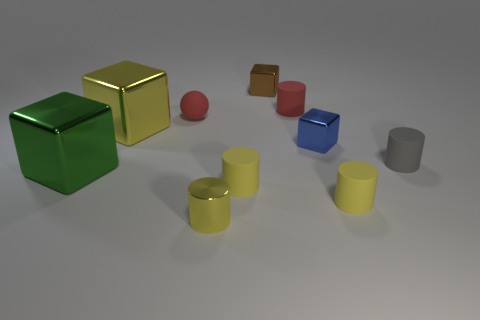Subtract all yellow cylinders. How many were subtracted if there are1yellow cylinders left? 2 Subtract all red blocks. How many yellow cylinders are left? 3 Subtract 3 cylinders. How many cylinders are left? 2 Subtract all gray cylinders. How many cylinders are left? 4 Subtract all small metallic cylinders. How many cylinders are left? 4 Subtract all red cubes. Subtract all yellow balls. How many cubes are left? 4 Subtract all spheres. How many objects are left? 9 Add 5 big blocks. How many big blocks exist? 7 Subtract 1 gray cylinders. How many objects are left? 9 Subtract all yellow cubes. Subtract all blocks. How many objects are left? 5 